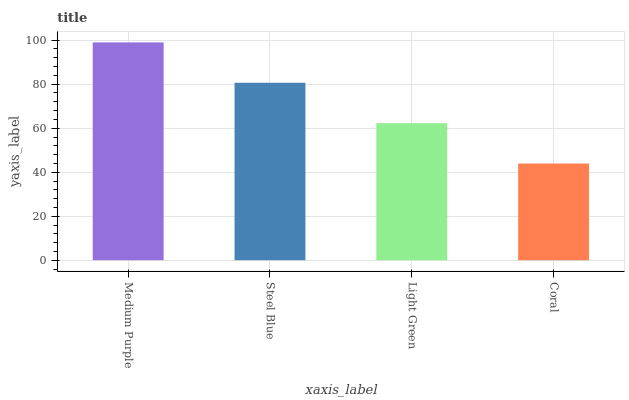Is Coral the minimum?
Answer yes or no. Yes. Is Medium Purple the maximum?
Answer yes or no. Yes. Is Steel Blue the minimum?
Answer yes or no. No. Is Steel Blue the maximum?
Answer yes or no. No. Is Medium Purple greater than Steel Blue?
Answer yes or no. Yes. Is Steel Blue less than Medium Purple?
Answer yes or no. Yes. Is Steel Blue greater than Medium Purple?
Answer yes or no. No. Is Medium Purple less than Steel Blue?
Answer yes or no. No. Is Steel Blue the high median?
Answer yes or no. Yes. Is Light Green the low median?
Answer yes or no. Yes. Is Light Green the high median?
Answer yes or no. No. Is Coral the low median?
Answer yes or no. No. 